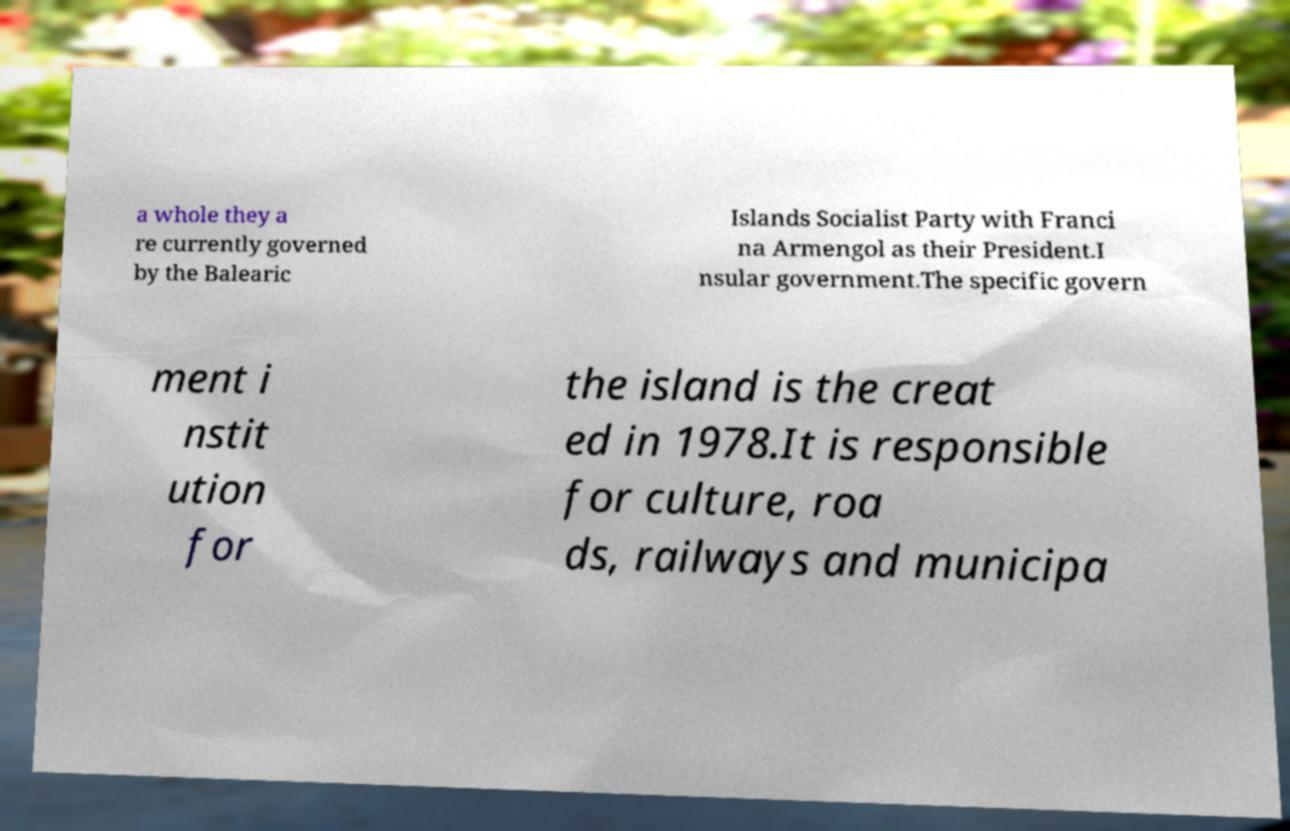Please read and relay the text visible in this image. What does it say? a whole they a re currently governed by the Balearic Islands Socialist Party with Franci na Armengol as their President.I nsular government.The specific govern ment i nstit ution for the island is the creat ed in 1978.It is responsible for culture, roa ds, railways and municipa 